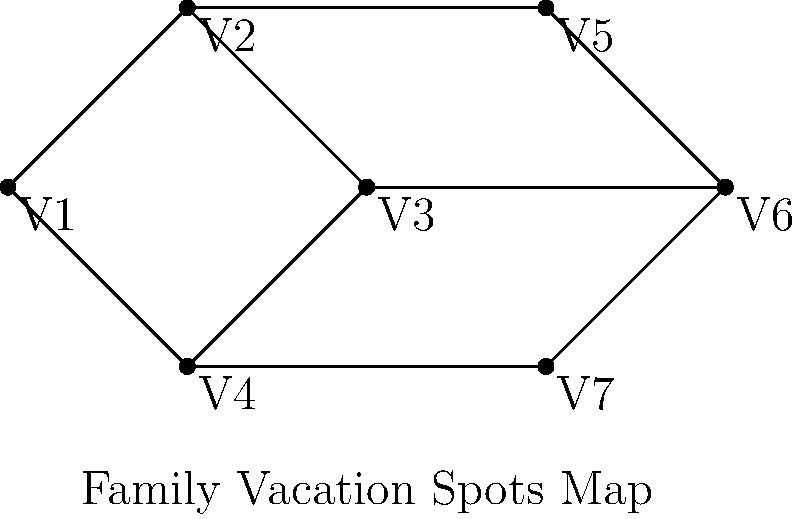Your family is planning a vacation and has mapped out potential destinations as shown above. Each vertex represents a different location, and connected vertices are adjacent regions. What is the minimum number of colors needed to color this map such that no adjacent regions have the same color? How does this relate to the chromatic number in graph theory? To solve this problem, we'll use the concept of graph coloring from graph theory:

1. Analyze the graph structure:
   - The graph has 7 vertices (V1 to V7)
   - It forms two interconnected cycles

2. Apply the greedy coloring algorithm:
   - Start with V1: Assign color 1
   - V2: Adjacent to V1, assign color 2
   - V3: Adjacent to V2, assign color 3
   - V4: Adjacent to V1 and V3, assign color 2
   - V5: Adjacent to V2, assign color 1
   - V6: Adjacent to V3 and V5, assign color 2
   - V7: Adjacent to V4 and V6, assign color 1

3. Count the number of colors used: 3

4. Verify that no adjacent vertices have the same color

5. Relate to graph theory:
   - The chromatic number $\chi(G)$ is the minimum number of colors needed to color a graph
   - In this case, $\chi(G) = 3$

6. Consider the family context:
   - This coloring allows for planning diverse experiences in adjacent regions
   - It encourages open-mindedness by exploring different types of locations
Answer: 3 colors; chromatic number $\chi(G) = 3$ 